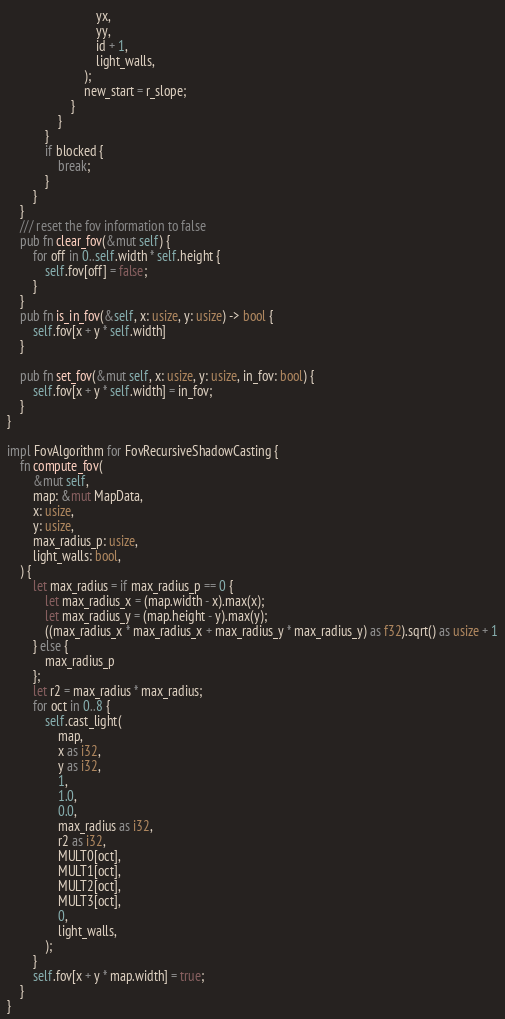<code> <loc_0><loc_0><loc_500><loc_500><_Rust_>                            yx,
                            yy,
                            id + 1,
                            light_walls,
                        );
                        new_start = r_slope;
                    }
                }
            }
            if blocked {
                break;
            }
        }
    }
    /// reset the fov information to false
    pub fn clear_fov(&mut self) {
        for off in 0..self.width * self.height {
            self.fov[off] = false;
        }
    }
    pub fn is_in_fov(&self, x: usize, y: usize) -> bool {
        self.fov[x + y * self.width]
    }
    
    pub fn set_fov(&mut self, x: usize, y: usize, in_fov: bool) {
        self.fov[x + y * self.width] = in_fov;
    }
}

impl FovAlgorithm for FovRecursiveShadowCasting {
    fn compute_fov(
        &mut self,
        map: &mut MapData,
        x: usize,
        y: usize,
        max_radius_p: usize,
        light_walls: bool,
    ) {
        let max_radius = if max_radius_p == 0 {
            let max_radius_x = (map.width - x).max(x);
            let max_radius_y = (map.height - y).max(y);
            ((max_radius_x * max_radius_x + max_radius_y * max_radius_y) as f32).sqrt() as usize + 1
        } else {
            max_radius_p
        };
        let r2 = max_radius * max_radius;
        for oct in 0..8 {
            self.cast_light(
                map,
                x as i32,
                y as i32,
                1,
                1.0,
                0.0,
                max_radius as i32,
                r2 as i32,
                MULT0[oct],
                MULT1[oct],
                MULT2[oct],
                MULT3[oct],
                0,
                light_walls,
            );
        }
        self.fov[x + y * map.width] = true;
    }
}
</code> 